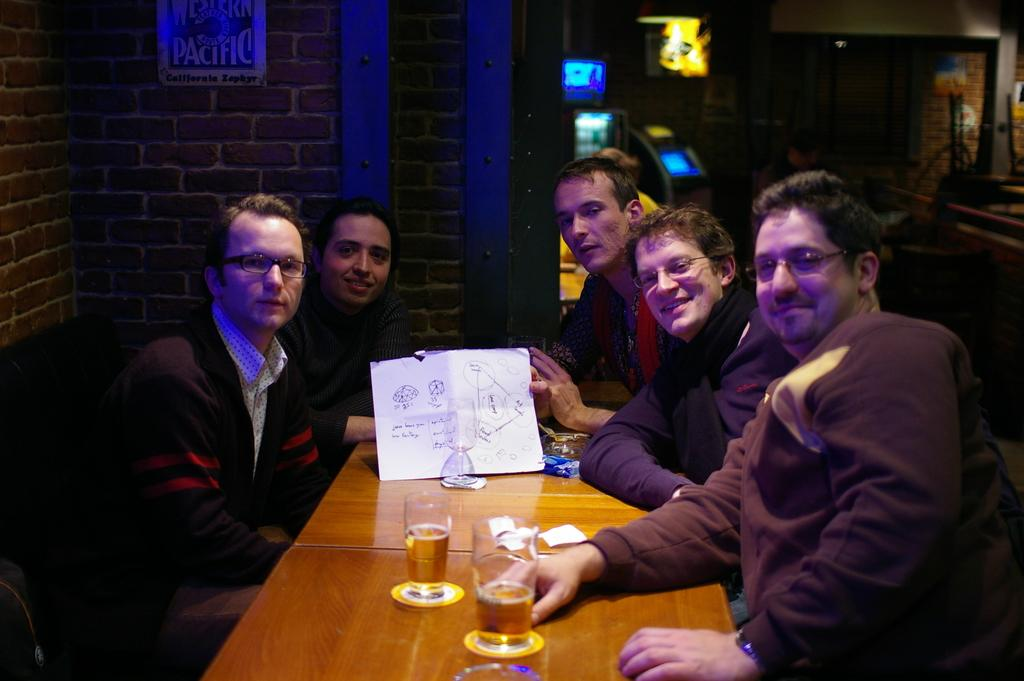How many people are sitting in the image? There are five people sitting on chairs in the image. What can be seen on the table in the image? There is a glass with a drink on a table in the image. What is visible in the background of the image? There is a wall in the background of the image. What type of front experience can be seen on the people's faces in the image? There is no indication of a specific front experience on the people's faces in the image. What hope do the people have for the future, as depicted in the image? There is no information about the people's hopes for the future in the image. 